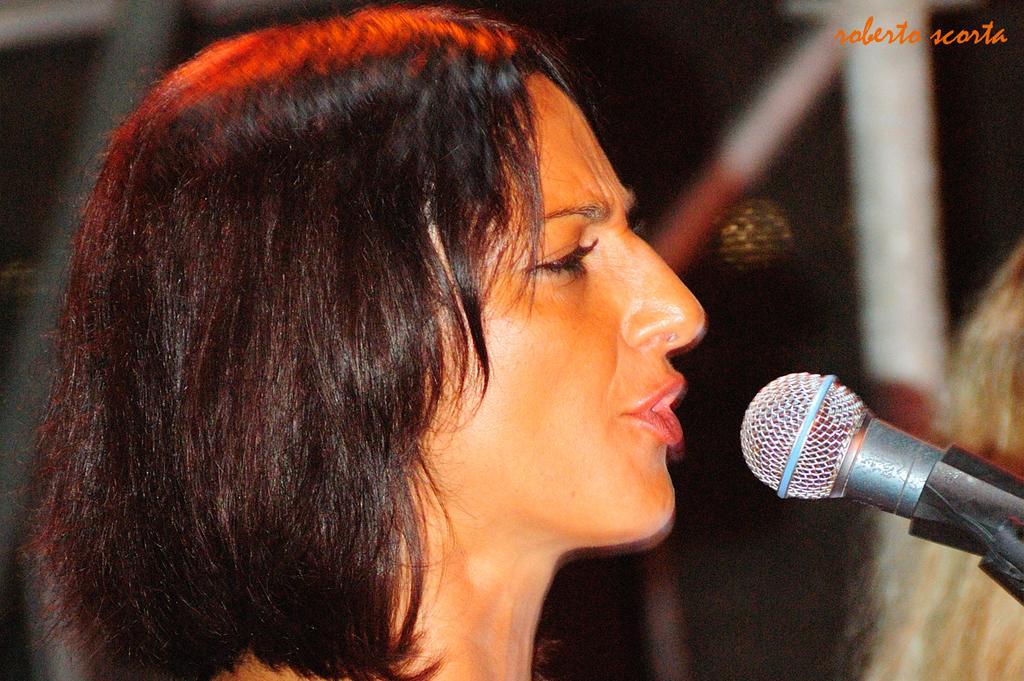In one or two sentences, can you explain what this image depicts? In the image there is a woman and it looks like she is singing a song, there is a mic in front of her, the background of the woman is blur. 